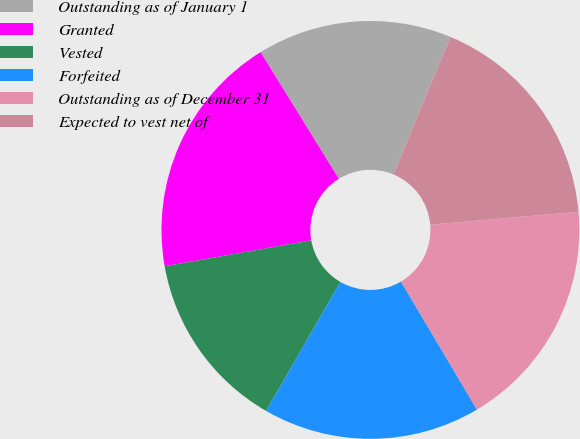<chart> <loc_0><loc_0><loc_500><loc_500><pie_chart><fcel>Outstanding as of January 1<fcel>Granted<fcel>Vested<fcel>Forfeited<fcel>Outstanding as of December 31<fcel>Expected to vest net of<nl><fcel>15.07%<fcel>18.98%<fcel>13.89%<fcel>16.84%<fcel>17.86%<fcel>17.35%<nl></chart> 